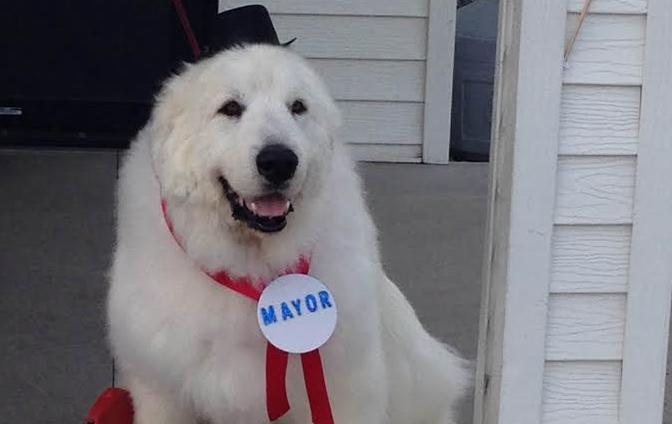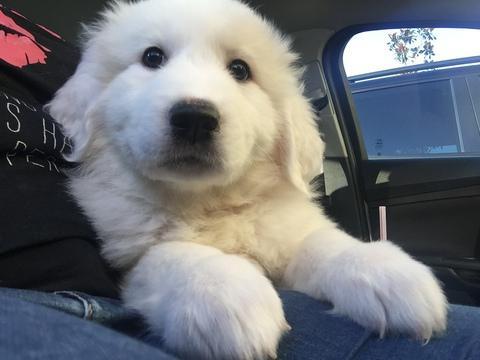The first image is the image on the left, the second image is the image on the right. Considering the images on both sides, is "An image includes a person wearing jeans inside a vehicle with one white dog." valid? Answer yes or no. Yes. The first image is the image on the left, the second image is the image on the right. Given the left and right images, does the statement "The dog in the image on the right is with a human in a vehicle." hold true? Answer yes or no. Yes. 